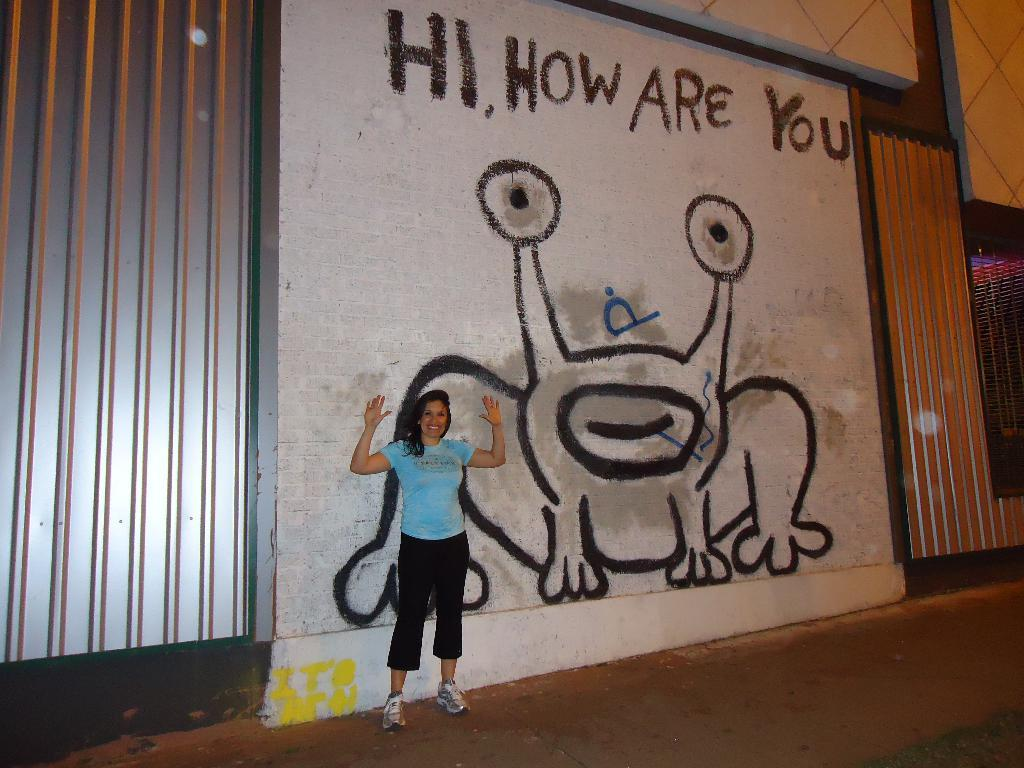What is the woman in the image doing? The woman is standing in the image and smiling. What can be seen behind the woman? There is a wall behind the woman. What is on the wall? There is a picture on the wall, and there is text above the picture. Can you tell me how many horses are depicted in the text above the picture on the wall? There are no horses mentioned in the text above the picture on the wall. What type of cracker is the woman holding in the image? The woman is not holding a cracker in the image. 